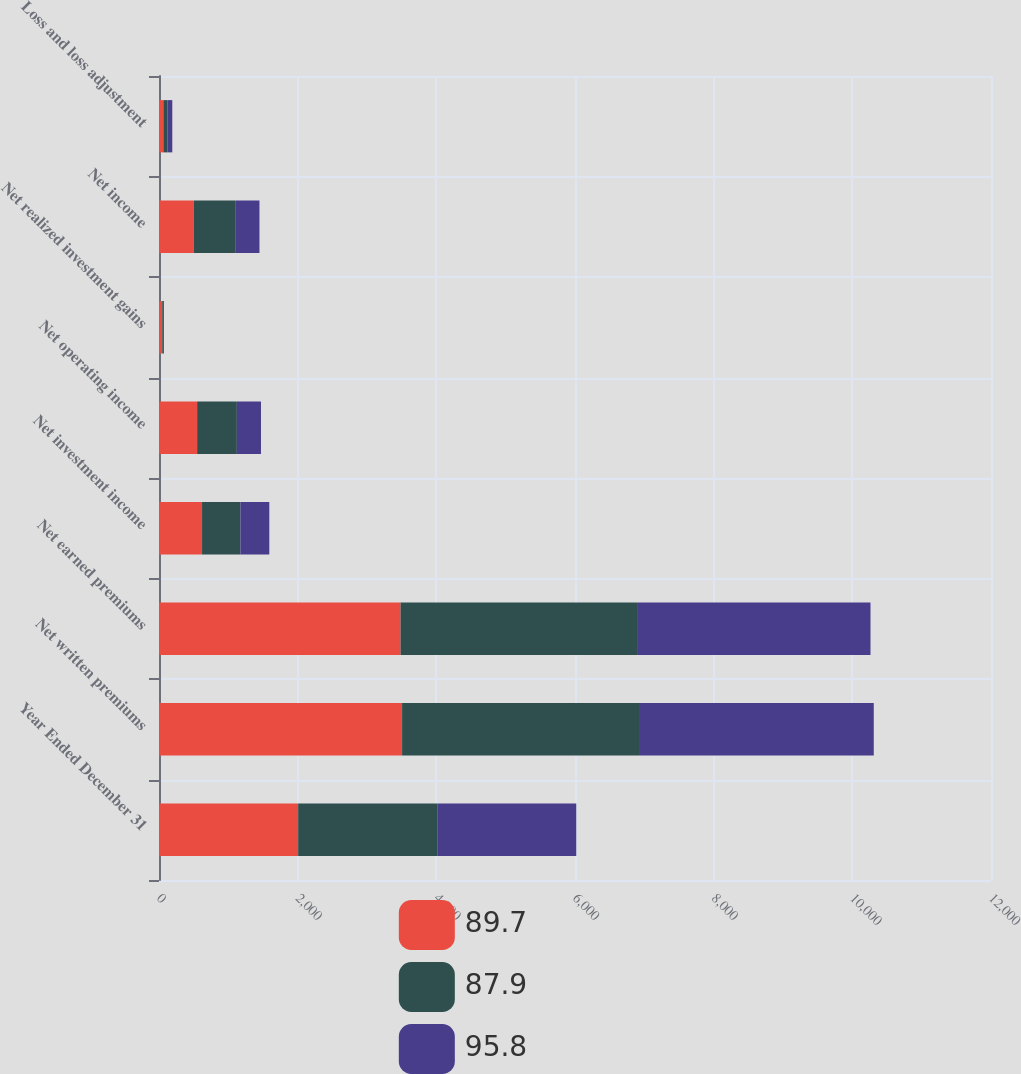Convert chart. <chart><loc_0><loc_0><loc_500><loc_500><stacked_bar_chart><ecel><fcel>Year Ended December 31<fcel>Net written premiums<fcel>Net earned premiums<fcel>Net investment income<fcel>Net operating income<fcel>Net realized investment gains<fcel>Net income<fcel>Loss and loss adjustment<nl><fcel>89.7<fcel>2007<fcel>3506<fcel>3484<fcel>621<fcel>550<fcel>47<fcel>503<fcel>62.8<nl><fcel>87.9<fcel>2006<fcel>3431<fcel>3411<fcel>554<fcel>573<fcel>23<fcel>596<fcel>60.4<nl><fcel>95.8<fcel>2005<fcel>3372<fcel>3367<fcel>416<fcel>348<fcel>2<fcel>350<fcel>68.3<nl></chart> 